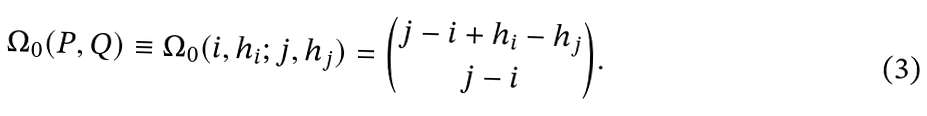Convert formula to latex. <formula><loc_0><loc_0><loc_500><loc_500>\Omega _ { 0 } ( P , Q ) \equiv \Omega _ { 0 } ( i , h _ { i } ; j , h _ { j } ) = \binom { j - i + h _ { i } - h _ { j } } { j - i } .</formula> 